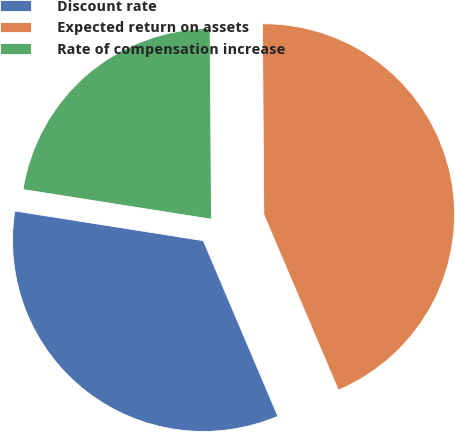Convert chart to OTSL. <chart><loc_0><loc_0><loc_500><loc_500><pie_chart><fcel>Discount rate<fcel>Expected return on assets<fcel>Rate of compensation increase<nl><fcel>33.88%<fcel>43.72%<fcel>22.4%<nl></chart> 